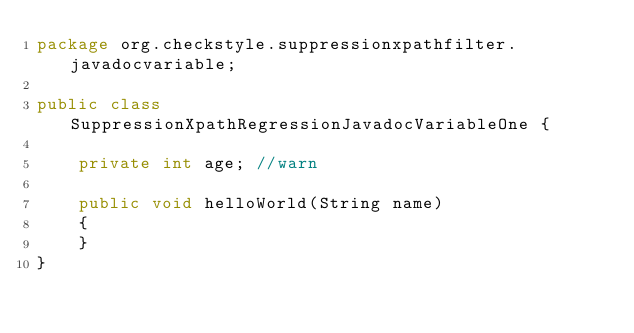Convert code to text. <code><loc_0><loc_0><loc_500><loc_500><_Java_>package org.checkstyle.suppressionxpathfilter.javadocvariable;

public class SuppressionXpathRegressionJavadocVariableOne {

    private int age; //warn

    public void helloWorld(String name)
    {
    }
}
</code> 